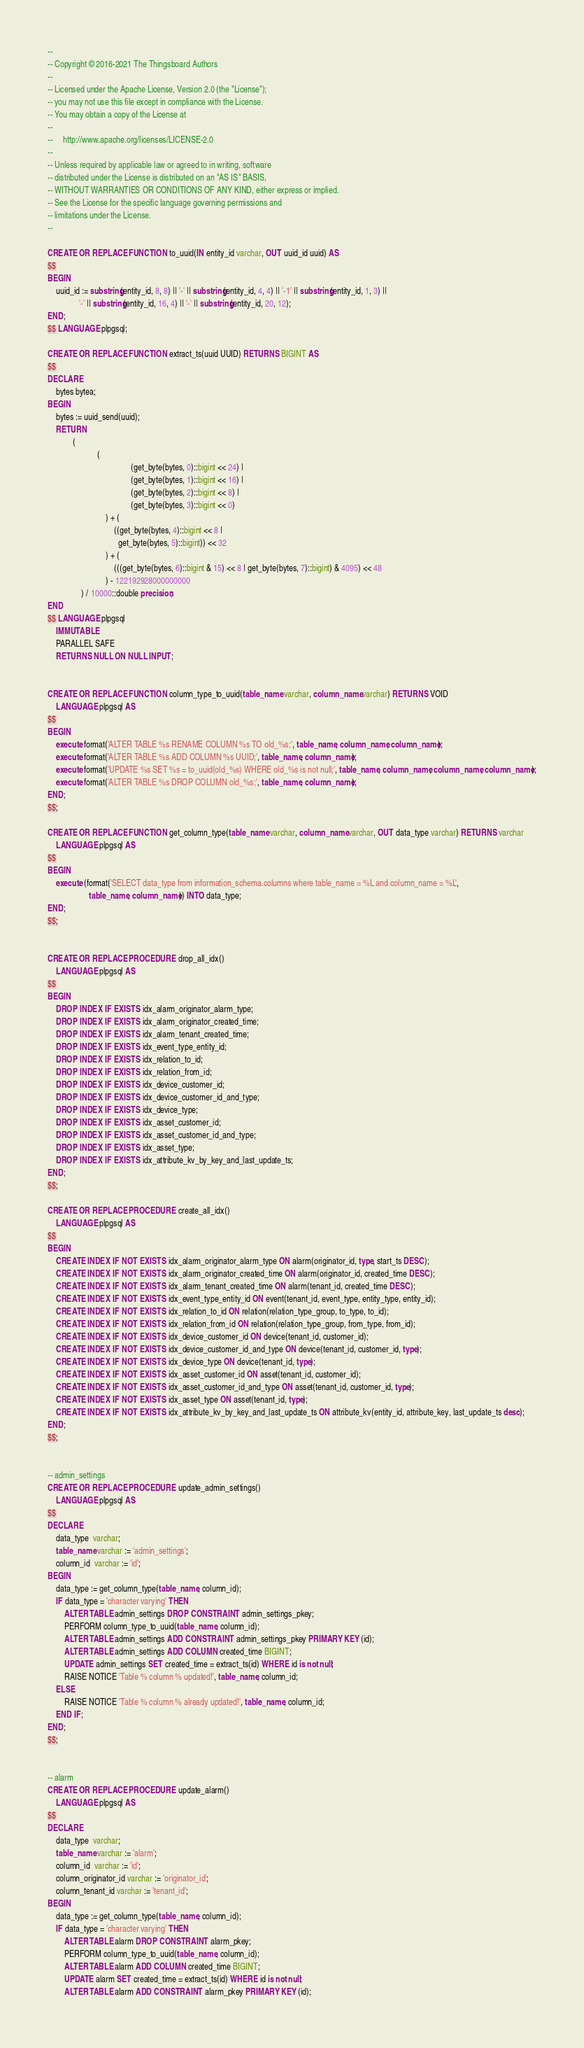Convert code to text. <code><loc_0><loc_0><loc_500><loc_500><_SQL_>--
-- Copyright © 2016-2021 The Thingsboard Authors
--
-- Licensed under the Apache License, Version 2.0 (the "License");
-- you may not use this file except in compliance with the License.
-- You may obtain a copy of the License at
--
--     http://www.apache.org/licenses/LICENSE-2.0
--
-- Unless required by applicable law or agreed to in writing, software
-- distributed under the License is distributed on an "AS IS" BASIS,
-- WITHOUT WARRANTIES OR CONDITIONS OF ANY KIND, either express or implied.
-- See the License for the specific language governing permissions and
-- limitations under the License.
--

CREATE OR REPLACE FUNCTION to_uuid(IN entity_id varchar, OUT uuid_id uuid) AS
$$
BEGIN
    uuid_id := substring(entity_id, 8, 8) || '-' || substring(entity_id, 4, 4) || '-1' || substring(entity_id, 1, 3) ||
               '-' || substring(entity_id, 16, 4) || '-' || substring(entity_id, 20, 12);
END;
$$ LANGUAGE plpgsql;

CREATE OR REPLACE FUNCTION extract_ts(uuid UUID) RETURNS BIGINT AS
$$
DECLARE
    bytes bytea;
BEGIN
    bytes := uuid_send(uuid);
    RETURN
            (
                        (
                                        (get_byte(bytes, 0)::bigint << 24) |
                                        (get_byte(bytes, 1)::bigint << 16) |
                                        (get_byte(bytes, 2)::bigint << 8) |
                                        (get_byte(bytes, 3)::bigint << 0)
                            ) + (
                                ((get_byte(bytes, 4)::bigint << 8 |
                                  get_byte(bytes, 5)::bigint)) << 32
                            ) + (
                                (((get_byte(bytes, 6)::bigint & 15) << 8 | get_byte(bytes, 7)::bigint) & 4095) << 48
                            ) - 122192928000000000
                ) / 10000::double precision;
END
$$ LANGUAGE plpgsql
    IMMUTABLE
    PARALLEL SAFE
    RETURNS NULL ON NULL INPUT;


CREATE OR REPLACE FUNCTION column_type_to_uuid(table_name varchar, column_name varchar) RETURNS VOID
    LANGUAGE plpgsql AS
$$
BEGIN
    execute format('ALTER TABLE %s RENAME COLUMN %s TO old_%s;', table_name, column_name, column_name);
    execute format('ALTER TABLE %s ADD COLUMN %s UUID;', table_name, column_name);
    execute format('UPDATE %s SET %s = to_uuid(old_%s) WHERE old_%s is not null;', table_name, column_name, column_name, column_name);
    execute format('ALTER TABLE %s DROP COLUMN old_%s;', table_name, column_name);
END;
$$;

CREATE OR REPLACE FUNCTION get_column_type(table_name varchar, column_name varchar, OUT data_type varchar) RETURNS varchar
    LANGUAGE plpgsql AS
$$
BEGIN
    execute (format('SELECT data_type from information_schema.columns where table_name = %L and column_name = %L',
                    table_name, column_name)) INTO data_type;
END;
$$;


CREATE OR REPLACE PROCEDURE drop_all_idx()
    LANGUAGE plpgsql AS
$$
BEGIN
    DROP INDEX IF EXISTS idx_alarm_originator_alarm_type;
    DROP INDEX IF EXISTS idx_alarm_originator_created_time;
    DROP INDEX IF EXISTS idx_alarm_tenant_created_time;
    DROP INDEX IF EXISTS idx_event_type_entity_id;
    DROP INDEX IF EXISTS idx_relation_to_id;
    DROP INDEX IF EXISTS idx_relation_from_id;
    DROP INDEX IF EXISTS idx_device_customer_id;
    DROP INDEX IF EXISTS idx_device_customer_id_and_type;
    DROP INDEX IF EXISTS idx_device_type;
    DROP INDEX IF EXISTS idx_asset_customer_id;
    DROP INDEX IF EXISTS idx_asset_customer_id_and_type;
    DROP INDEX IF EXISTS idx_asset_type;
    DROP INDEX IF EXISTS idx_attribute_kv_by_key_and_last_update_ts;
END;
$$;

CREATE OR REPLACE PROCEDURE create_all_idx()
    LANGUAGE plpgsql AS
$$
BEGIN
    CREATE INDEX IF NOT EXISTS idx_alarm_originator_alarm_type ON alarm(originator_id, type, start_ts DESC);
    CREATE INDEX IF NOT EXISTS idx_alarm_originator_created_time ON alarm(originator_id, created_time DESC);
    CREATE INDEX IF NOT EXISTS idx_alarm_tenant_created_time ON alarm(tenant_id, created_time DESC);
    CREATE INDEX IF NOT EXISTS idx_event_type_entity_id ON event(tenant_id, event_type, entity_type, entity_id);
    CREATE INDEX IF NOT EXISTS idx_relation_to_id ON relation(relation_type_group, to_type, to_id);
    CREATE INDEX IF NOT EXISTS idx_relation_from_id ON relation(relation_type_group, from_type, from_id);
    CREATE INDEX IF NOT EXISTS idx_device_customer_id ON device(tenant_id, customer_id);
    CREATE INDEX IF NOT EXISTS idx_device_customer_id_and_type ON device(tenant_id, customer_id, type);
    CREATE INDEX IF NOT EXISTS idx_device_type ON device(tenant_id, type);
    CREATE INDEX IF NOT EXISTS idx_asset_customer_id ON asset(tenant_id, customer_id);
    CREATE INDEX IF NOT EXISTS idx_asset_customer_id_and_type ON asset(tenant_id, customer_id, type);
    CREATE INDEX IF NOT EXISTS idx_asset_type ON asset(tenant_id, type);
    CREATE INDEX IF NOT EXISTS idx_attribute_kv_by_key_and_last_update_ts ON attribute_kv(entity_id, attribute_key, last_update_ts desc);
END;
$$;


-- admin_settings
CREATE OR REPLACE PROCEDURE update_admin_settings()
    LANGUAGE plpgsql AS
$$
DECLARE
    data_type  varchar;
    table_name varchar := 'admin_settings';
    column_id  varchar := 'id';
BEGIN
    data_type := get_column_type(table_name, column_id);
    IF data_type = 'character varying' THEN
        ALTER TABLE admin_settings DROP CONSTRAINT admin_settings_pkey;
        PERFORM column_type_to_uuid(table_name, column_id);
        ALTER TABLE admin_settings ADD CONSTRAINT admin_settings_pkey PRIMARY KEY (id);
        ALTER TABLE admin_settings ADD COLUMN created_time BIGINT;
        UPDATE admin_settings SET created_time = extract_ts(id) WHERE id is not null;
        RAISE NOTICE 'Table % column % updated!', table_name, column_id;
    ELSE
        RAISE NOTICE 'Table % column % already updated!', table_name, column_id;
    END IF;
END;
$$;


-- alarm
CREATE OR REPLACE PROCEDURE update_alarm()
    LANGUAGE plpgsql AS
$$
DECLARE
    data_type  varchar;
    table_name varchar := 'alarm';
    column_id  varchar := 'id';
    column_originator_id varchar := 'originator_id';
    column_tenant_id varchar := 'tenant_id';
BEGIN
    data_type := get_column_type(table_name, column_id);
    IF data_type = 'character varying' THEN
        ALTER TABLE alarm DROP CONSTRAINT alarm_pkey;
        PERFORM column_type_to_uuid(table_name, column_id);
        ALTER TABLE alarm ADD COLUMN created_time BIGINT;
        UPDATE alarm SET created_time = extract_ts(id) WHERE id is not null;
        ALTER TABLE alarm ADD CONSTRAINT alarm_pkey PRIMARY KEY (id);</code> 